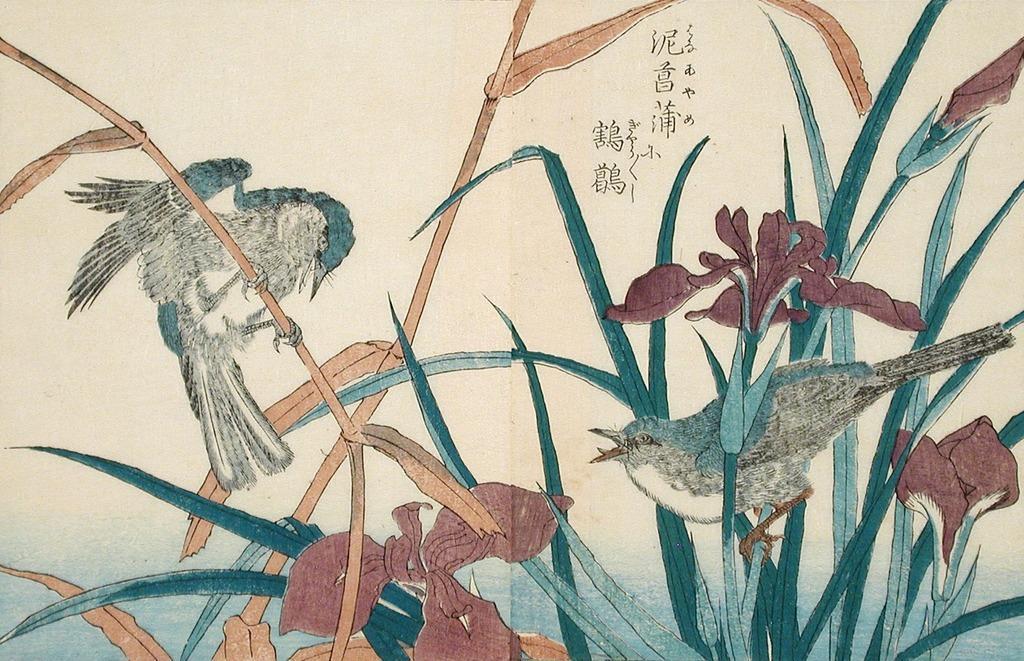How would you summarize this image in a sentence or two? In this picture there is a drawing art on the paper. In the front there are two bird on the plants and red color flowers. 